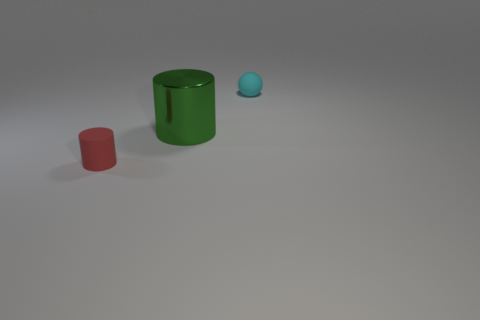Add 2 small cyan spheres. How many objects exist? 5 Subtract all cylinders. How many objects are left? 1 Add 1 brown metallic balls. How many brown metallic balls exist? 1 Subtract 0 green spheres. How many objects are left? 3 Subtract all big green things. Subtract all green shiny objects. How many objects are left? 1 Add 3 red cylinders. How many red cylinders are left? 4 